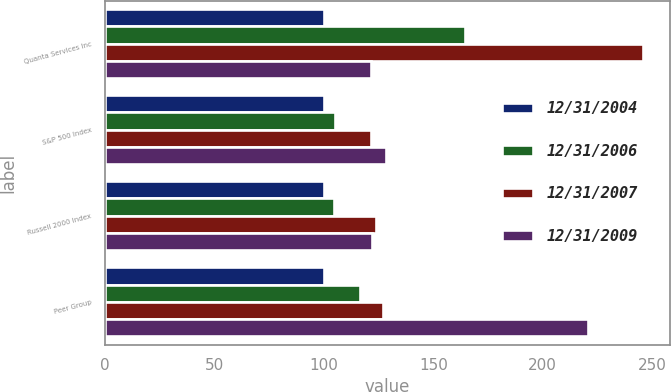Convert chart. <chart><loc_0><loc_0><loc_500><loc_500><stacked_bar_chart><ecel><fcel>Quanta Services Inc<fcel>S&P 500 Index<fcel>Russell 2000 Index<fcel>Peer Group<nl><fcel>12/31/2004<fcel>100<fcel>100<fcel>100<fcel>100<nl><fcel>12/31/2006<fcel>164.63<fcel>104.91<fcel>104.55<fcel>116.54<nl><fcel>12/31/2007<fcel>245.88<fcel>121.48<fcel>123.76<fcel>126.84<nl><fcel>12/31/2009<fcel>121.48<fcel>128.16<fcel>121.82<fcel>220.93<nl></chart> 